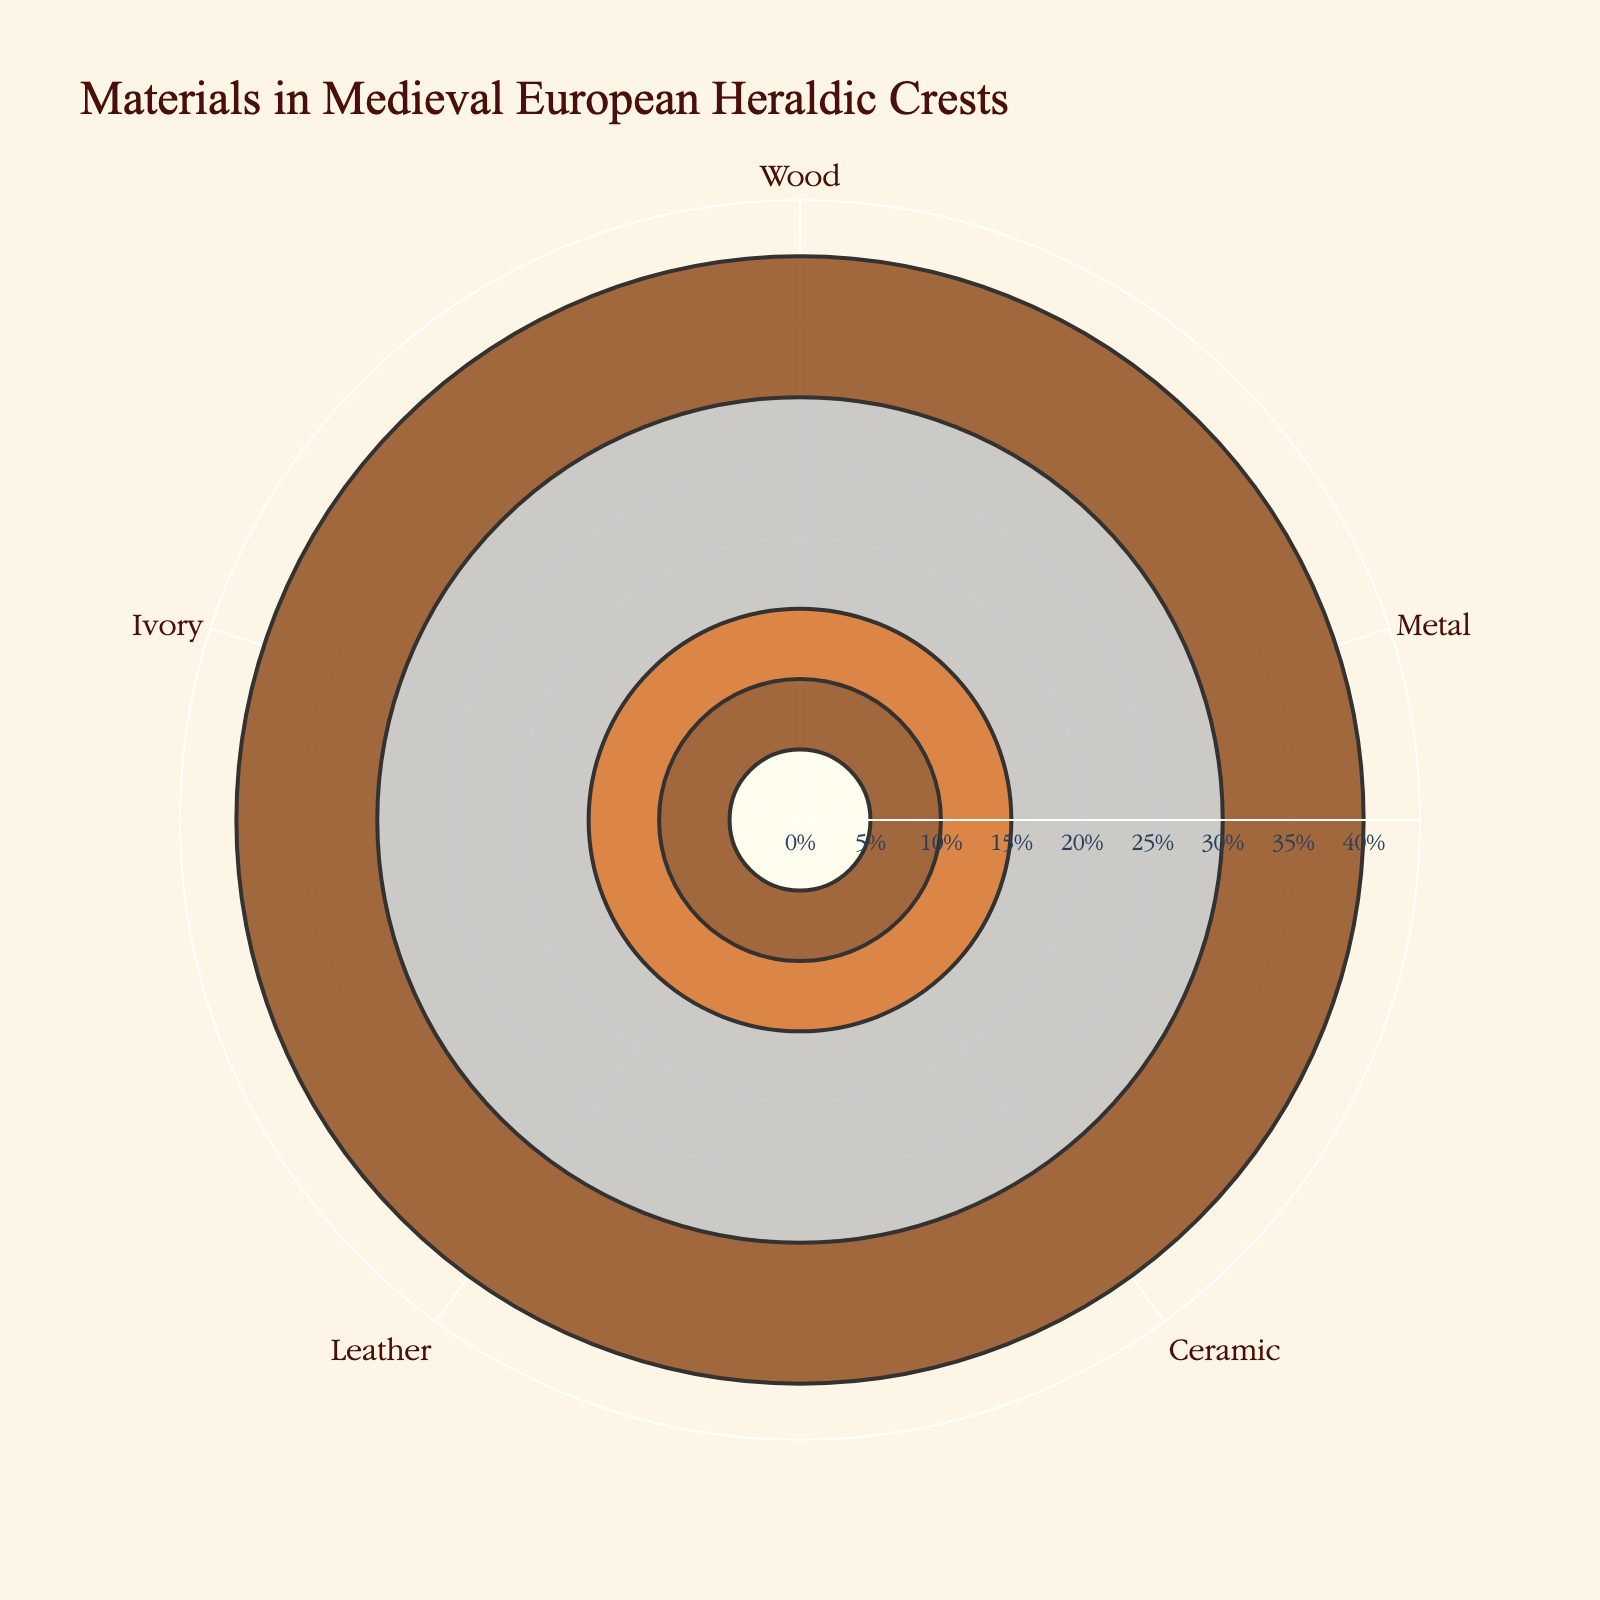Which material is used the most in Medieval European heraldic crests? The figure shows that the material with the highest percentage is located at the bar with the largest radial extension. Wood is at 40%, which is the highest among all materials.
Answer: Wood What is the title of the chart? The title of the chart is displayed at the top center of the figure. It reads "Materials in Medieval European Heraldic Crests".
Answer: Materials in Medieval European Heraldic Crests How many materials are listed in the figure? Count the number of distinct categories around the polar chart. The figure shows five unique materials.
Answer: 5 What percentage of materials used in heraldic crests are composed of non-metallic substances? Sum the percentages of Wood, Ceramic, Leather, and Ivory. Wood (40%) + Ceramic (15%) + Leather (10%) + Ivory (5%) = 70%.
Answer: 70% Compare the usage percentages of Metal and Ceramic. Which one is used more and by how much? Look at the radial distances corresponding to Metal and Ceramic. Metal has 30%, while Ceramic has 15%. The difference is 30% - 15% = 15%.
Answer: Metal by 15% What is the combined percentage of Leather and Ivory used in heraldic crests? Sum the percentages of Leather and Ivory. Leather is 10% and Ivory is 5%, so 10% + 5% = 15%.
Answer: 15% Which material has the least usage percentage, and what is that percentage? The smallest radial extension represents the material with the least usage, which is Ivory. The percentage is 5%.
Answer: Ivory, 5% What is the range of the radial axis? The range is given by the polar radial axis’ maximum and minimum values. The maximum value is slightly above the highest percentage (40%), denoted as going up to a bit beyond 40%. So, the range is from 0 to approximately 44%.
Answer: 0 to 44% Which material(s) share the same color in the chart, and what is their color? Identify which bars have the same color by visually inspecting the chart. Both Wood and Leather have the same brown color.
Answer: Wood and Leather, brown Arrange the materials in descending order based on their proportion in medieval heraldic crests. List the materials from the largest to the smallest percentage by comparing each radial distance around the polar chart. The order is Wood (40%), Metal (30%), Ceramic (15%), Leather (10%), and Ivory (5%).
Answer: Wood, Metal, Ceramic, Leather, Ivory 